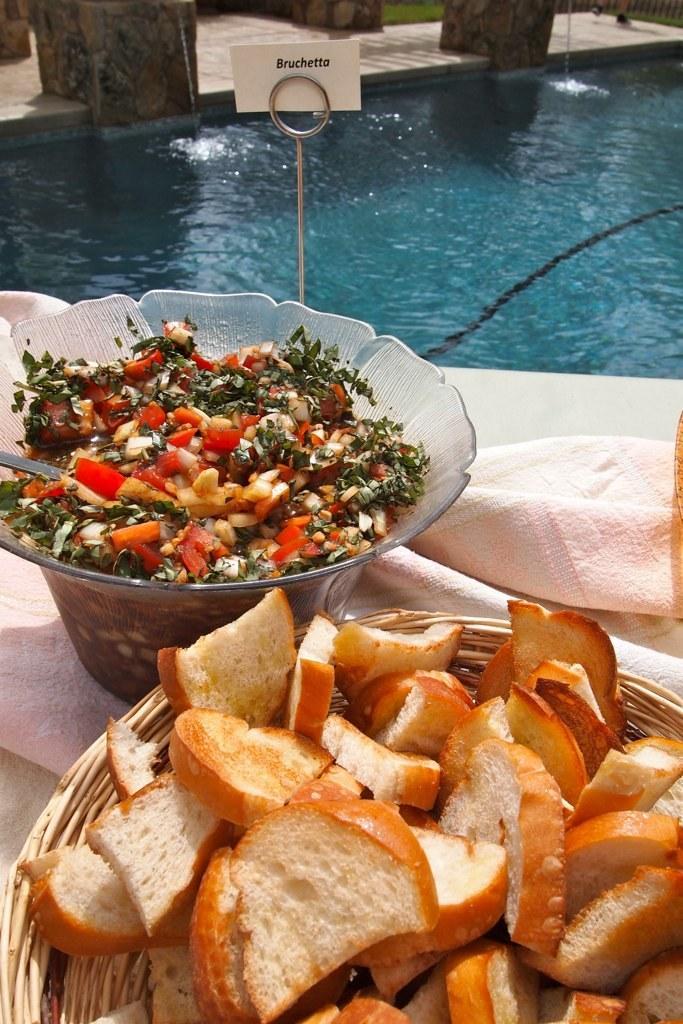Can you describe this image briefly? In this image we can see a group of bowls containing food placed on the table. On which a cloth ,stand with a card placed on it. In the background ,we can see water 